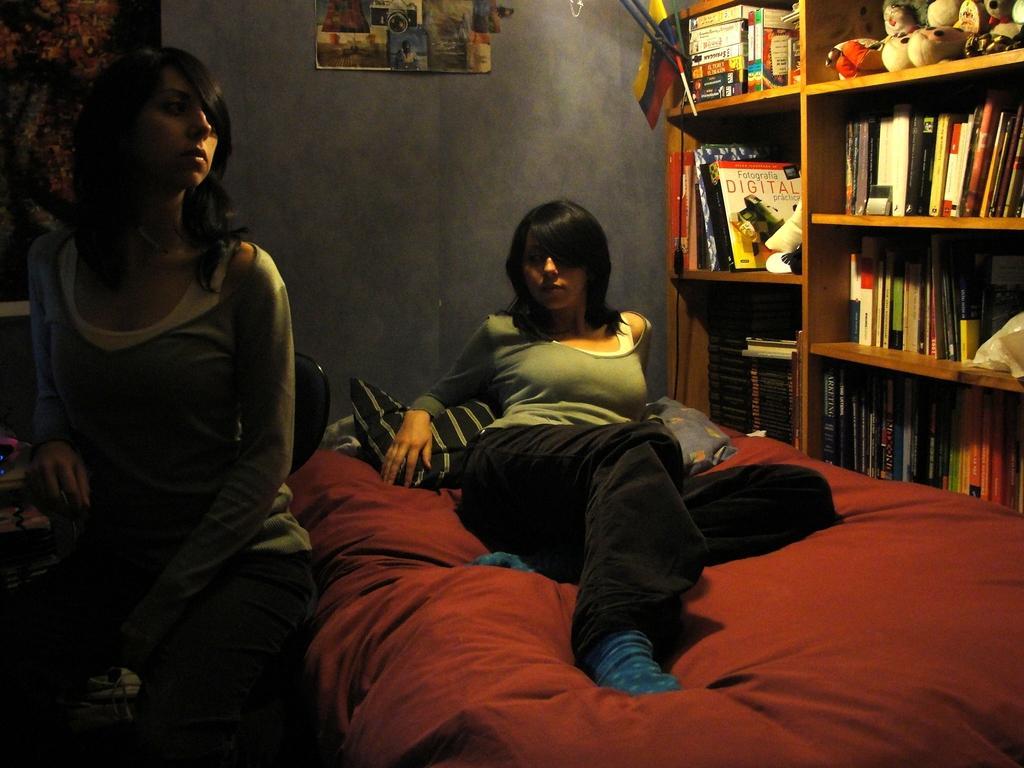Please provide a concise description of this image. This picture shows a woman laying on the bed and we see a woman seated on a chair and we see books in the bookshelf and a poster on the wall and we see couple of pillows 